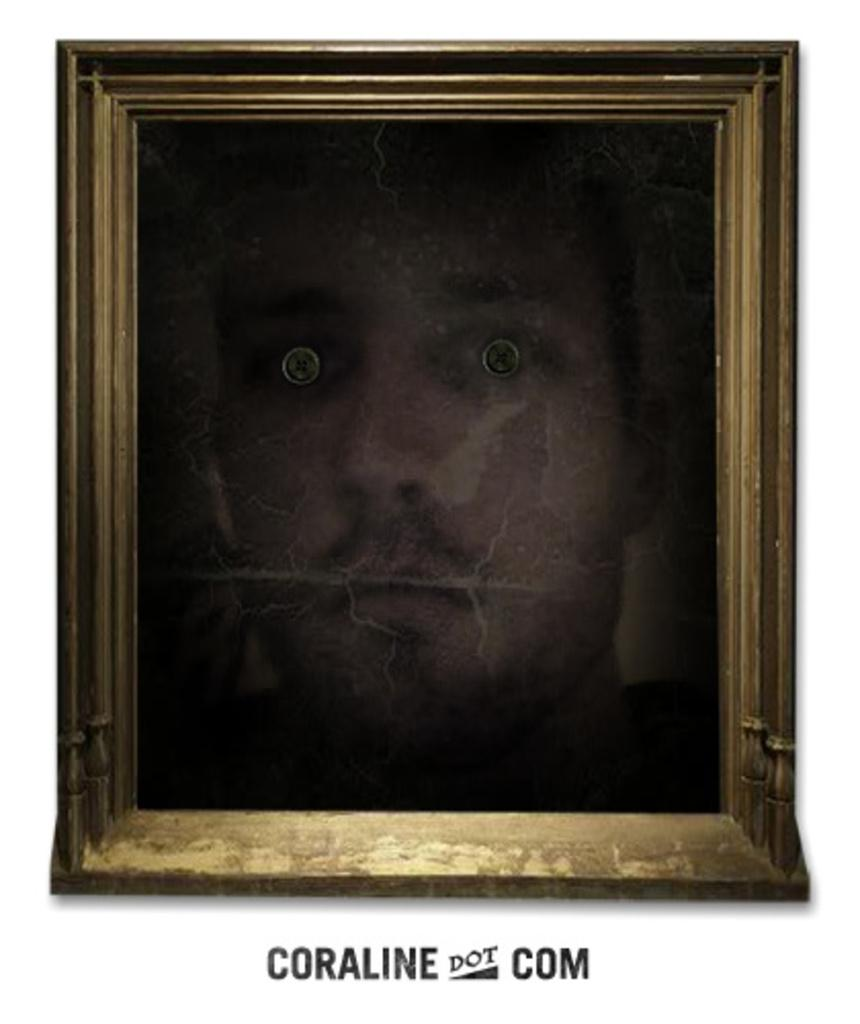<image>
Give a short and clear explanation of the subsequent image. A framed portrait of a man with strange eyes is set above the words "Coraline dot com". 